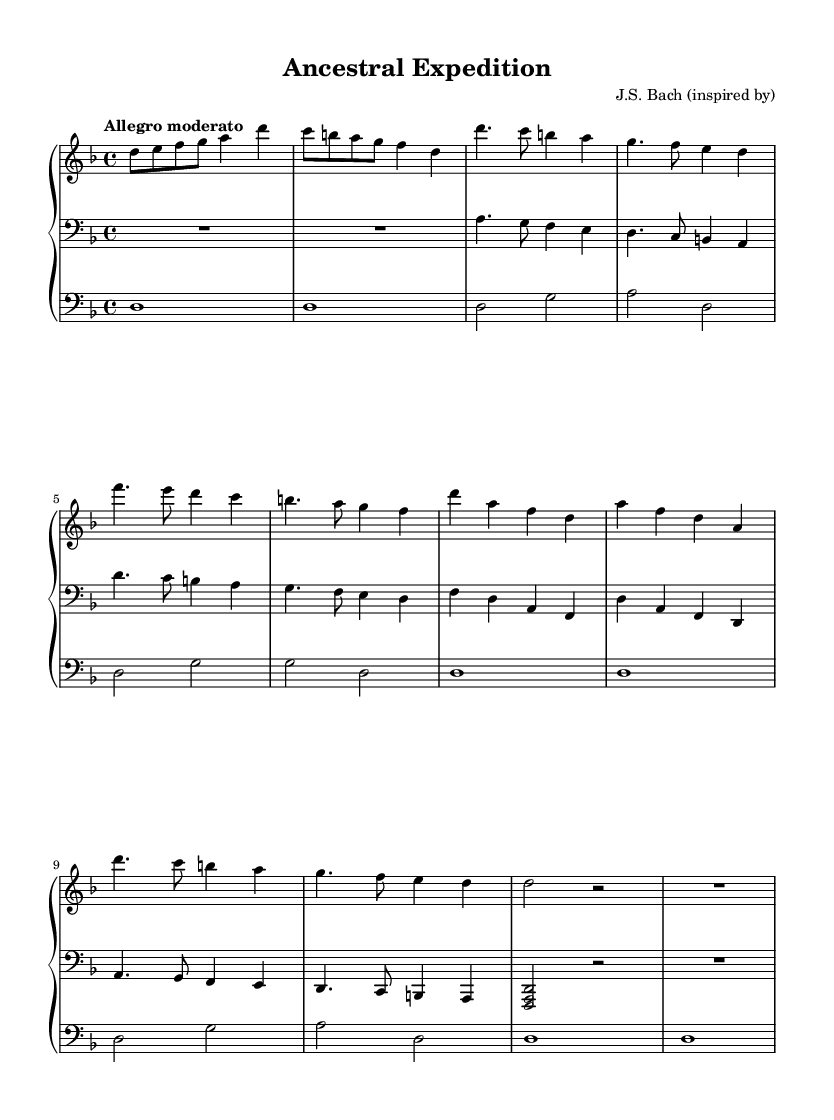What is the key signature of this music? The key signature is D minor, which has one flat (B flat) indicated by the key structure.
Answer: D minor What is the time signature of the piece? The time signature shown in the music is 4/4, meaning there are four beats per measure.
Answer: 4/4 What is the tempo marking of the piece? The tempo marking specified is "Allegro moderato," indicating a moderately fast speed.
Answer: Allegro moderato Which instrument is the piece arranged for? The arrangement lists "church organ" as the intended instrument for both the right and left hand parts, and pedal.
Answer: Church organ How many themes are present in the composition? There are two distinct themes labeled as Theme A and Theme B, each representing different melodic ideas utilized throughout the piece.
Answer: 2 What kind of counterpoint technique is used in the left-hand melody? The left-hand melody employs imitative counterpoint, which means that it echoes and develops the themes stated by the right hand, adding depth and interplay to the overall texture.
Answer: Imitative counterpoint How does the piece conclude? The piece concludes with a coda section characterized by a strong pedal point on D, reaffirming the tonal center and providing a satisfying resolution.
Answer: Pedal point on D 